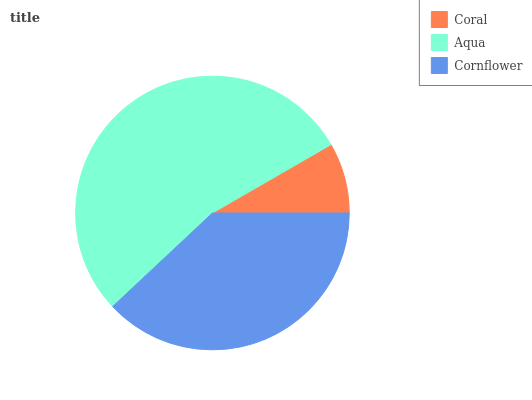Is Coral the minimum?
Answer yes or no. Yes. Is Aqua the maximum?
Answer yes or no. Yes. Is Cornflower the minimum?
Answer yes or no. No. Is Cornflower the maximum?
Answer yes or no. No. Is Aqua greater than Cornflower?
Answer yes or no. Yes. Is Cornflower less than Aqua?
Answer yes or no. Yes. Is Cornflower greater than Aqua?
Answer yes or no. No. Is Aqua less than Cornflower?
Answer yes or no. No. Is Cornflower the high median?
Answer yes or no. Yes. Is Cornflower the low median?
Answer yes or no. Yes. Is Coral the high median?
Answer yes or no. No. Is Coral the low median?
Answer yes or no. No. 